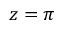<formula> <loc_0><loc_0><loc_500><loc_500>z = \pi</formula> 